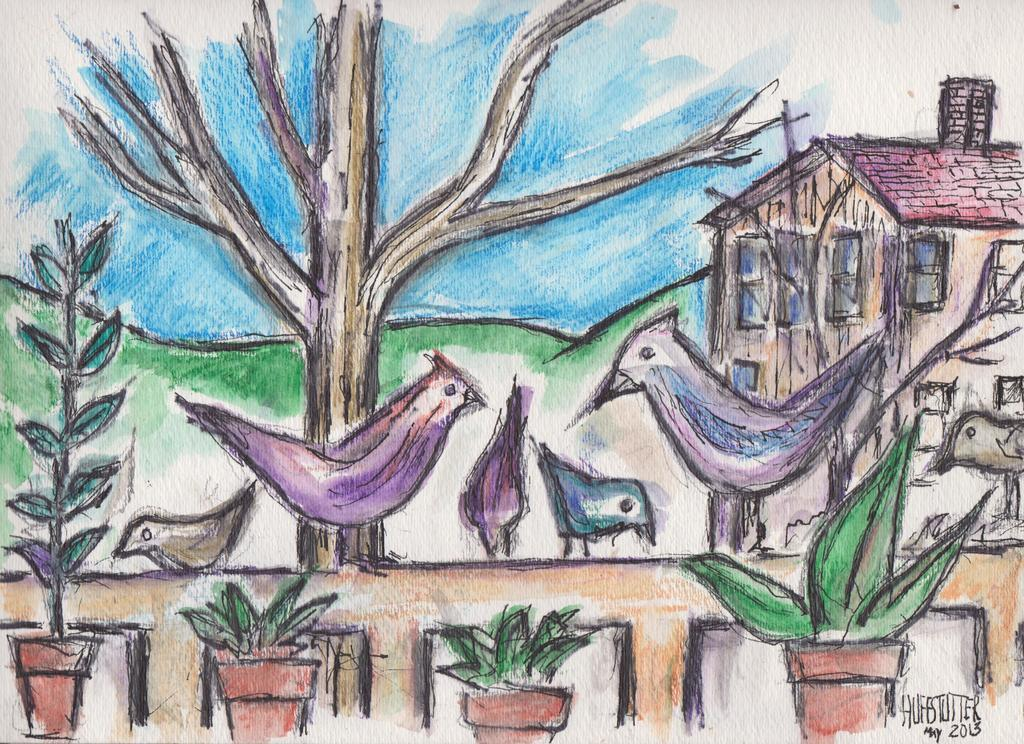What is the main subject of the drawing in the image? The main subject of the drawing is a house. What other elements can be seen in the drawing? There is a tree trunk, plants with a pot, a wall, birds, mountains, and sky visible in the drawing. Where is the text located in the image? The text is on the right side bottom of the image. Can you see a train passing by in the drawing? No, there is no train present in the drawing. What phase is the moon in the drawing? There is no moon depicted in the drawing. 